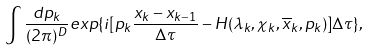Convert formula to latex. <formula><loc_0><loc_0><loc_500><loc_500>\int \frac { d p _ { k } } { ( 2 \pi ) ^ { D } } e x p \{ i [ p _ { k } \frac { x _ { k } - x _ { k - 1 } } { \Delta \tau } - H ( \lambda _ { k } , \chi _ { k } , \overline { x } _ { k } , p _ { k } ) ] \Delta \tau \} ,</formula> 